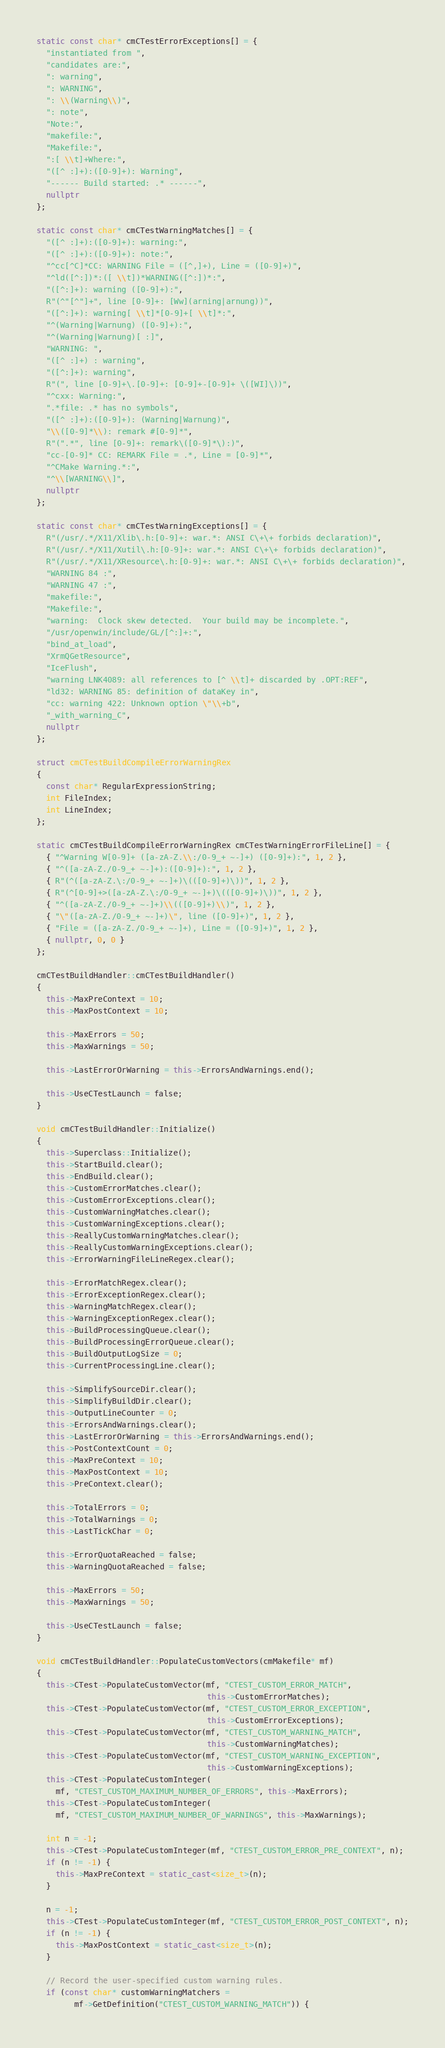Convert code to text. <code><loc_0><loc_0><loc_500><loc_500><_C++_>
static const char* cmCTestErrorExceptions[] = {
  "instantiated from ",
  "candidates are:",
  ": warning",
  ": WARNING",
  ": \\(Warning\\)",
  ": note",
  "Note:",
  "makefile:",
  "Makefile:",
  ":[ \\t]+Where:",
  "([^ :]+):([0-9]+): Warning",
  "------ Build started: .* ------",
  nullptr
};

static const char* cmCTestWarningMatches[] = {
  "([^ :]+):([0-9]+): warning:",
  "([^ :]+):([0-9]+): note:",
  "^cc[^C]*CC: WARNING File = ([^,]+), Line = ([0-9]+)",
  "^ld([^:])*:([ \\t])*WARNING([^:])*:",
  "([^:]+): warning ([0-9]+):",
  R"(^"[^"]+", line [0-9]+: [Ww](arning|arnung))",
  "([^:]+): warning[ \\t]*[0-9]+[ \\t]*:",
  "^(Warning|Warnung) ([0-9]+):",
  "^(Warning|Warnung)[ :]",
  "WARNING: ",
  "([^ :]+) : warning",
  "([^:]+): warning",
  R"(", line [0-9]+\.[0-9]+: [0-9]+-[0-9]+ \([WI]\))",
  "^cxx: Warning:",
  ".*file: .* has no symbols",
  "([^ :]+):([0-9]+): (Warning|Warnung)",
  "\\([0-9]*\\): remark #[0-9]*",
  R"(".*", line [0-9]+: remark\([0-9]*\):)",
  "cc-[0-9]* CC: REMARK File = .*, Line = [0-9]*",
  "^CMake Warning.*:",
  "^\\[WARNING\\]",
  nullptr
};

static const char* cmCTestWarningExceptions[] = {
  R"(/usr/.*/X11/Xlib\.h:[0-9]+: war.*: ANSI C\+\+ forbids declaration)",
  R"(/usr/.*/X11/Xutil\.h:[0-9]+: war.*: ANSI C\+\+ forbids declaration)",
  R"(/usr/.*/X11/XResource\.h:[0-9]+: war.*: ANSI C\+\+ forbids declaration)",
  "WARNING 84 :",
  "WARNING 47 :",
  "makefile:",
  "Makefile:",
  "warning:  Clock skew detected.  Your build may be incomplete.",
  "/usr/openwin/include/GL/[^:]+:",
  "bind_at_load",
  "XrmQGetResource",
  "IceFlush",
  "warning LNK4089: all references to [^ \\t]+ discarded by .OPT:REF",
  "ld32: WARNING 85: definition of dataKey in",
  "cc: warning 422: Unknown option \"\\+b",
  "_with_warning_C",
  nullptr
};

struct cmCTestBuildCompileErrorWarningRex
{
  const char* RegularExpressionString;
  int FileIndex;
  int LineIndex;
};

static cmCTestBuildCompileErrorWarningRex cmCTestWarningErrorFileLine[] = {
  { "^Warning W[0-9]+ ([a-zA-Z.\\:/0-9_+ ~-]+) ([0-9]+):", 1, 2 },
  { "^([a-zA-Z./0-9_+ ~-]+):([0-9]+):", 1, 2 },
  { R"(^([a-zA-Z.\:/0-9_+ ~-]+)\(([0-9]+)\))", 1, 2 },
  { R"(^[0-9]+>([a-zA-Z.\:/0-9_+ ~-]+)\(([0-9]+)\))", 1, 2 },
  { "^([a-zA-Z./0-9_+ ~-]+)\\(([0-9]+)\\)", 1, 2 },
  { "\"([a-zA-Z./0-9_+ ~-]+)\", line ([0-9]+)", 1, 2 },
  { "File = ([a-zA-Z./0-9_+ ~-]+), Line = ([0-9]+)", 1, 2 },
  { nullptr, 0, 0 }
};

cmCTestBuildHandler::cmCTestBuildHandler()
{
  this->MaxPreContext = 10;
  this->MaxPostContext = 10;

  this->MaxErrors = 50;
  this->MaxWarnings = 50;

  this->LastErrorOrWarning = this->ErrorsAndWarnings.end();

  this->UseCTestLaunch = false;
}

void cmCTestBuildHandler::Initialize()
{
  this->Superclass::Initialize();
  this->StartBuild.clear();
  this->EndBuild.clear();
  this->CustomErrorMatches.clear();
  this->CustomErrorExceptions.clear();
  this->CustomWarningMatches.clear();
  this->CustomWarningExceptions.clear();
  this->ReallyCustomWarningMatches.clear();
  this->ReallyCustomWarningExceptions.clear();
  this->ErrorWarningFileLineRegex.clear();

  this->ErrorMatchRegex.clear();
  this->ErrorExceptionRegex.clear();
  this->WarningMatchRegex.clear();
  this->WarningExceptionRegex.clear();
  this->BuildProcessingQueue.clear();
  this->BuildProcessingErrorQueue.clear();
  this->BuildOutputLogSize = 0;
  this->CurrentProcessingLine.clear();

  this->SimplifySourceDir.clear();
  this->SimplifyBuildDir.clear();
  this->OutputLineCounter = 0;
  this->ErrorsAndWarnings.clear();
  this->LastErrorOrWarning = this->ErrorsAndWarnings.end();
  this->PostContextCount = 0;
  this->MaxPreContext = 10;
  this->MaxPostContext = 10;
  this->PreContext.clear();

  this->TotalErrors = 0;
  this->TotalWarnings = 0;
  this->LastTickChar = 0;

  this->ErrorQuotaReached = false;
  this->WarningQuotaReached = false;

  this->MaxErrors = 50;
  this->MaxWarnings = 50;

  this->UseCTestLaunch = false;
}

void cmCTestBuildHandler::PopulateCustomVectors(cmMakefile* mf)
{
  this->CTest->PopulateCustomVector(mf, "CTEST_CUSTOM_ERROR_MATCH",
                                    this->CustomErrorMatches);
  this->CTest->PopulateCustomVector(mf, "CTEST_CUSTOM_ERROR_EXCEPTION",
                                    this->CustomErrorExceptions);
  this->CTest->PopulateCustomVector(mf, "CTEST_CUSTOM_WARNING_MATCH",
                                    this->CustomWarningMatches);
  this->CTest->PopulateCustomVector(mf, "CTEST_CUSTOM_WARNING_EXCEPTION",
                                    this->CustomWarningExceptions);
  this->CTest->PopulateCustomInteger(
    mf, "CTEST_CUSTOM_MAXIMUM_NUMBER_OF_ERRORS", this->MaxErrors);
  this->CTest->PopulateCustomInteger(
    mf, "CTEST_CUSTOM_MAXIMUM_NUMBER_OF_WARNINGS", this->MaxWarnings);

  int n = -1;
  this->CTest->PopulateCustomInteger(mf, "CTEST_CUSTOM_ERROR_PRE_CONTEXT", n);
  if (n != -1) {
    this->MaxPreContext = static_cast<size_t>(n);
  }

  n = -1;
  this->CTest->PopulateCustomInteger(mf, "CTEST_CUSTOM_ERROR_POST_CONTEXT", n);
  if (n != -1) {
    this->MaxPostContext = static_cast<size_t>(n);
  }

  // Record the user-specified custom warning rules.
  if (const char* customWarningMatchers =
        mf->GetDefinition("CTEST_CUSTOM_WARNING_MATCH")) {</code> 